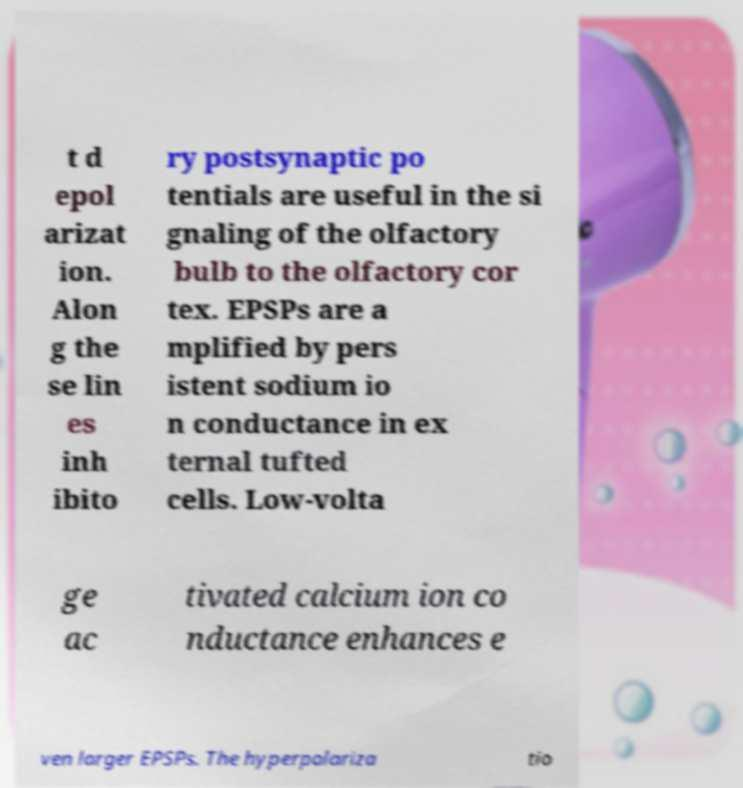Please identify and transcribe the text found in this image. t d epol arizat ion. Alon g the se lin es inh ibito ry postsynaptic po tentials are useful in the si gnaling of the olfactory bulb to the olfactory cor tex. EPSPs are a mplified by pers istent sodium io n conductance in ex ternal tufted cells. Low-volta ge ac tivated calcium ion co nductance enhances e ven larger EPSPs. The hyperpolariza tio 